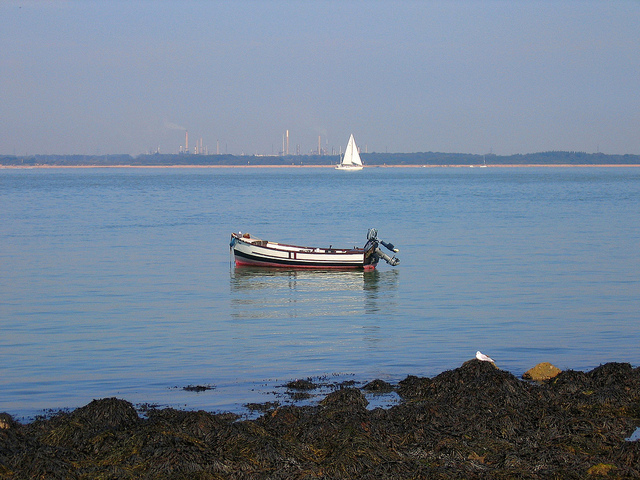How would you describe the current weather conditions? The weather appears to be clear and sunny, with excellent visibility, which is great for day-time marine activities. The state of the sea is calm, suggesting light winds, which benefits the sailboat in the distance harnessing the breeze without high waves. Could this location be suitable for swimming? Considering the calm water and clear skies, this coastal area could be suitable for swimming. However, depending on the local conditions, such as water temperature and currents, it might be necessary to exercise caution. Additionally, the presence of seaweed suggests it's a natural and less-manicured beachfront, which some swimmers might find off-putting. 